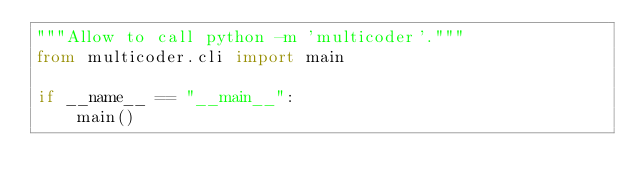Convert code to text. <code><loc_0><loc_0><loc_500><loc_500><_Python_>"""Allow to call python -m 'multicoder'."""
from multicoder.cli import main

if __name__ == "__main__":
    main()
</code> 